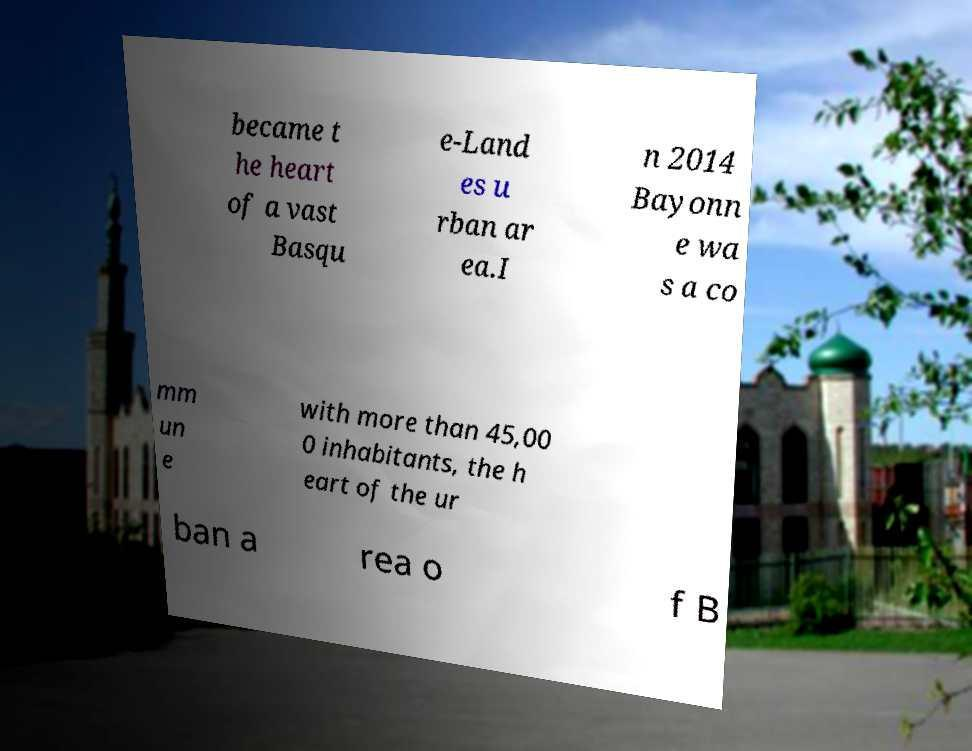Could you assist in decoding the text presented in this image and type it out clearly? became t he heart of a vast Basqu e-Land es u rban ar ea.I n 2014 Bayonn e wa s a co mm un e with more than 45,00 0 inhabitants, the h eart of the ur ban a rea o f B 